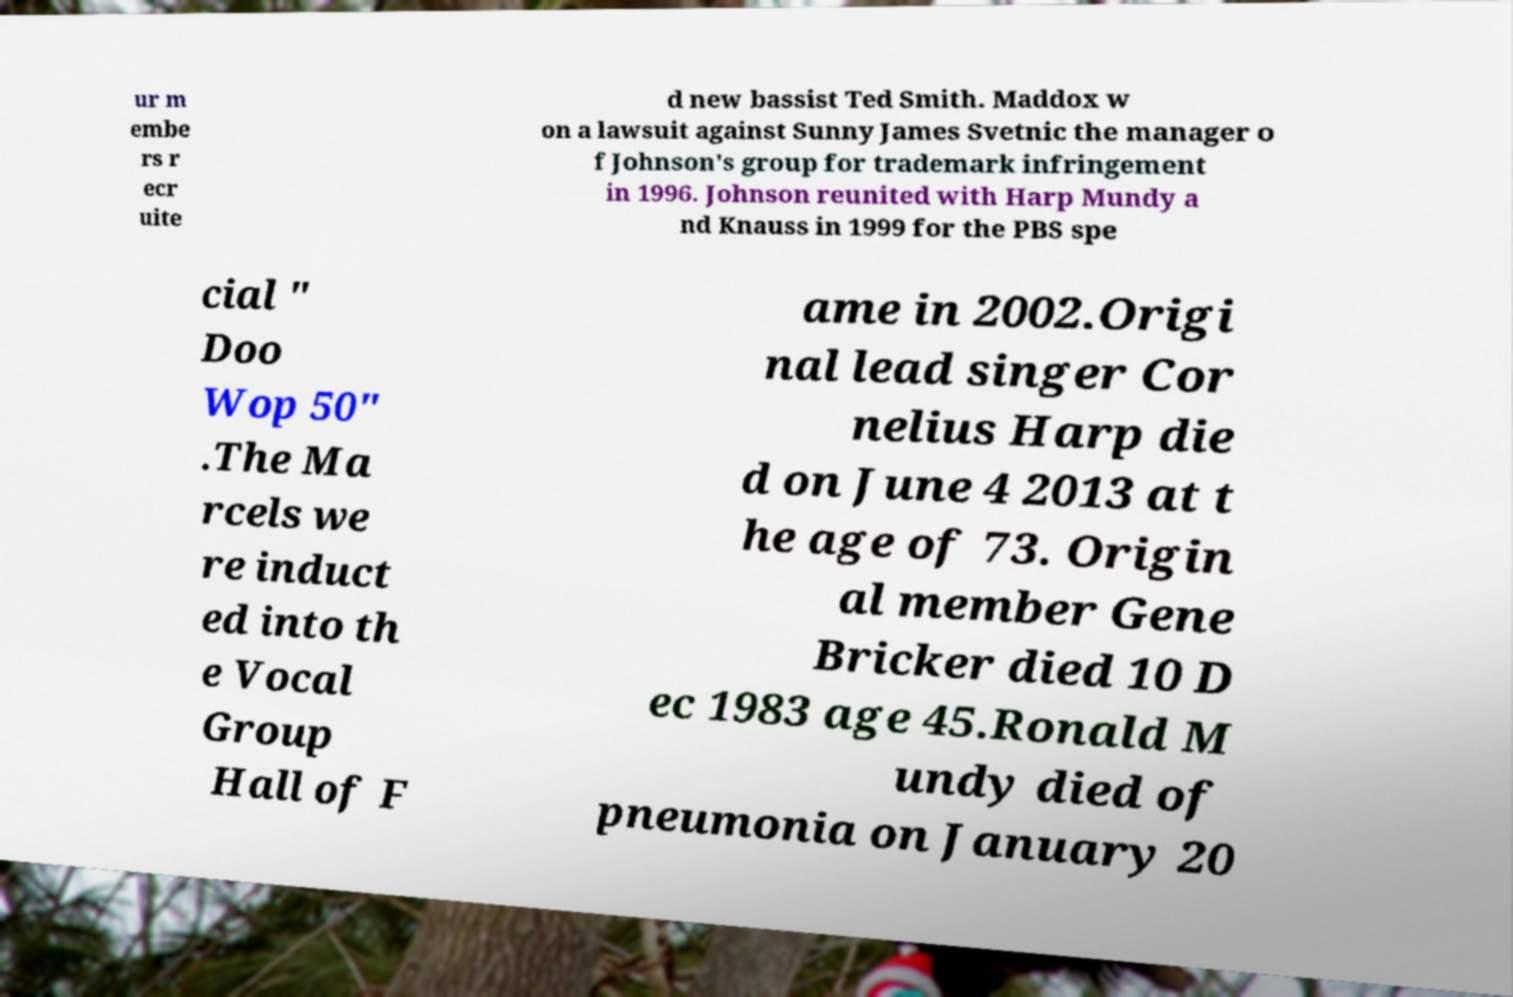Please identify and transcribe the text found in this image. ur m embe rs r ecr uite d new bassist Ted Smith. Maddox w on a lawsuit against Sunny James Svetnic the manager o f Johnson's group for trademark infringement in 1996. Johnson reunited with Harp Mundy a nd Knauss in 1999 for the PBS spe cial " Doo Wop 50" .The Ma rcels we re induct ed into th e Vocal Group Hall of F ame in 2002.Origi nal lead singer Cor nelius Harp die d on June 4 2013 at t he age of 73. Origin al member Gene Bricker died 10 D ec 1983 age 45.Ronald M undy died of pneumonia on January 20 